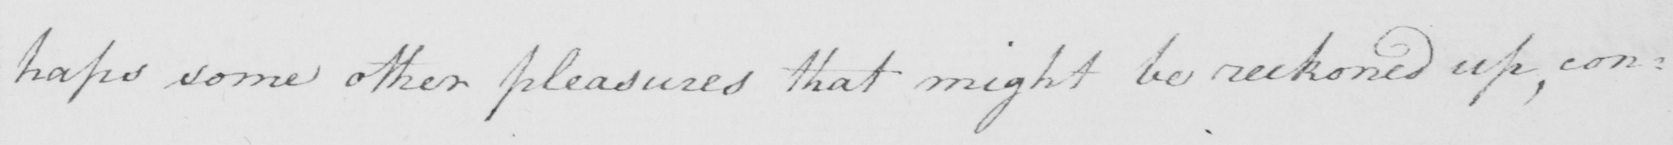What is written in this line of handwriting? : haps some other pleasures that might be reckoned up , con : 